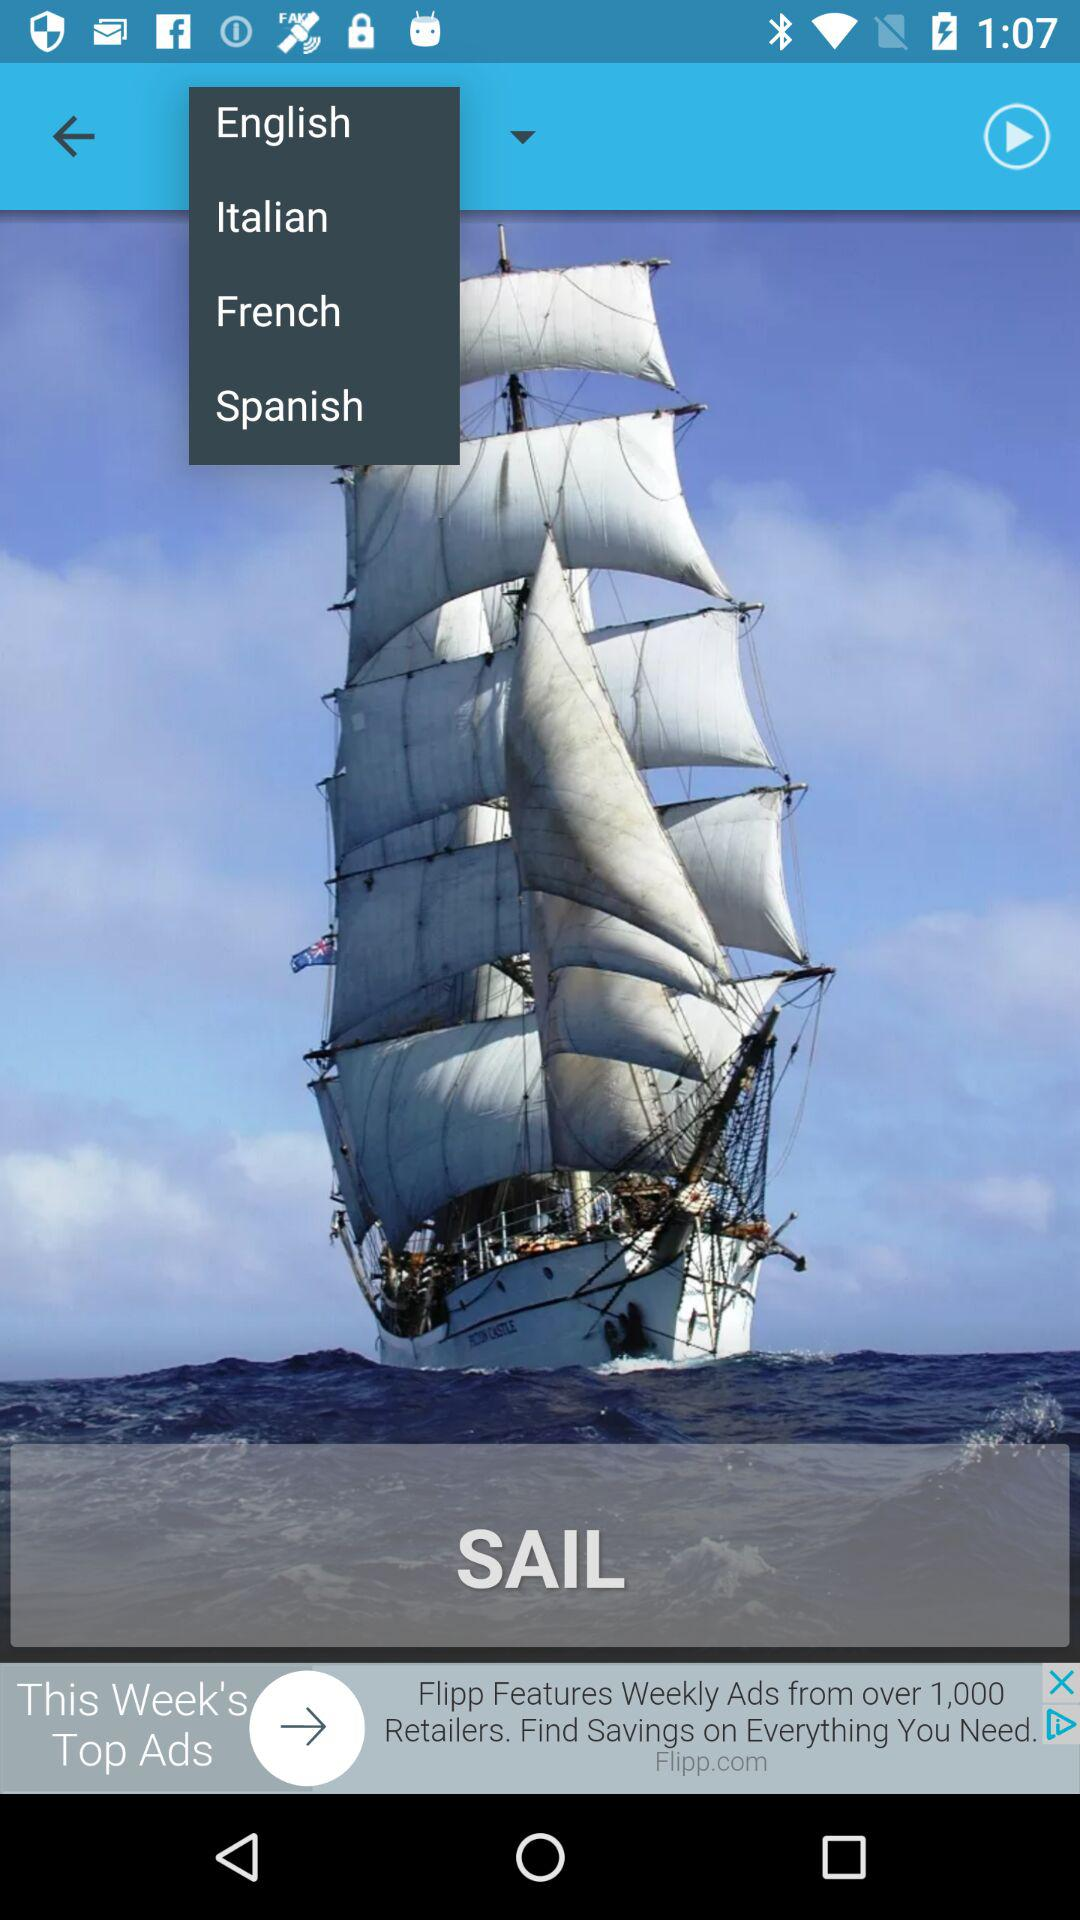Which language has been mentioned in the drop down menu? The mentioned languages are English, Italian, French and Spanish. 